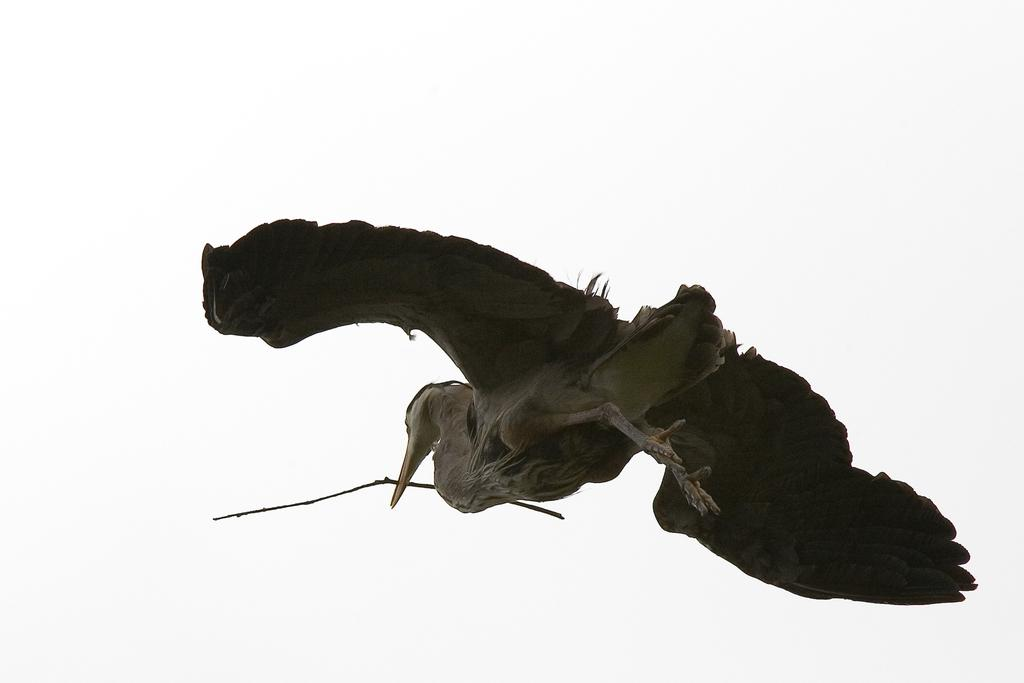What type of animal can be seen in the image? There is a bird in the image. Can you describe the color of the bird? The bird is black and cream in color. What is the bird doing in the image? The bird is flying in the air. What is the bird holding in its mouth? The bird is holding a stick in its mouth. What is the color of the background in the image? The background of the image is white. What type of curtain can be seen hanging from the bridge in the image? There is no bridge or curtain present in the image. What type of drink is the bird holding in its mouth? The bird is not holding a drink in its mouth; it is holding a stick. 